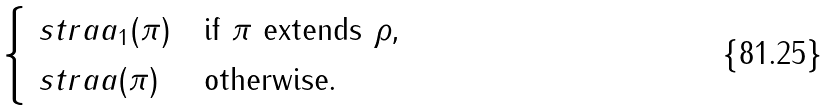<formula> <loc_0><loc_0><loc_500><loc_500>\begin{cases} \ s t r a a _ { 1 } ( \pi ) & \text {if $\pi$ extends $\rho$,} \\ \ s t r a a ( \pi ) & \text {otherwise.} \end{cases}</formula> 